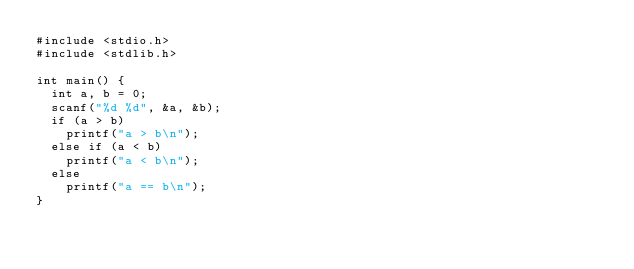Convert code to text. <code><loc_0><loc_0><loc_500><loc_500><_C_>#include <stdio.h>
#include <stdlib.h>

int main() {
	int a, b = 0;
	scanf("%d %d", &a, &b);
	if (a > b)
		printf("a > b\n");
	else if (a < b)
		printf("a < b\n");
	else
		printf("a == b\n");
}
</code> 